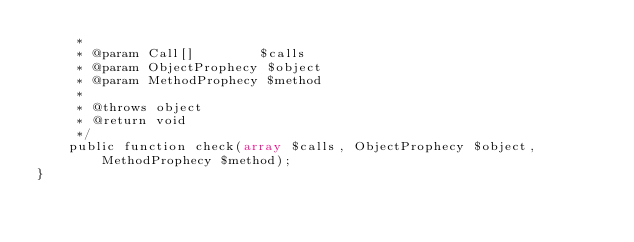<code> <loc_0><loc_0><loc_500><loc_500><_PHP_>     *
     * @param Call[]        $calls
     * @param ObjectProphecy $object
     * @param MethodProphecy $method
     *
     * @throws object
     * @return void
     */
    public function check(array $calls, ObjectProphecy $object, MethodProphecy $method);
}
</code> 